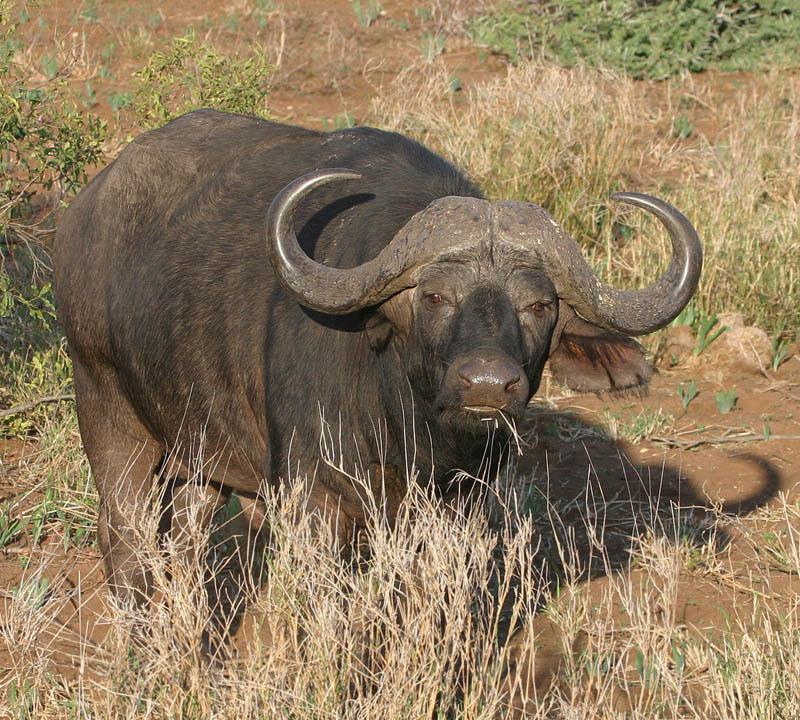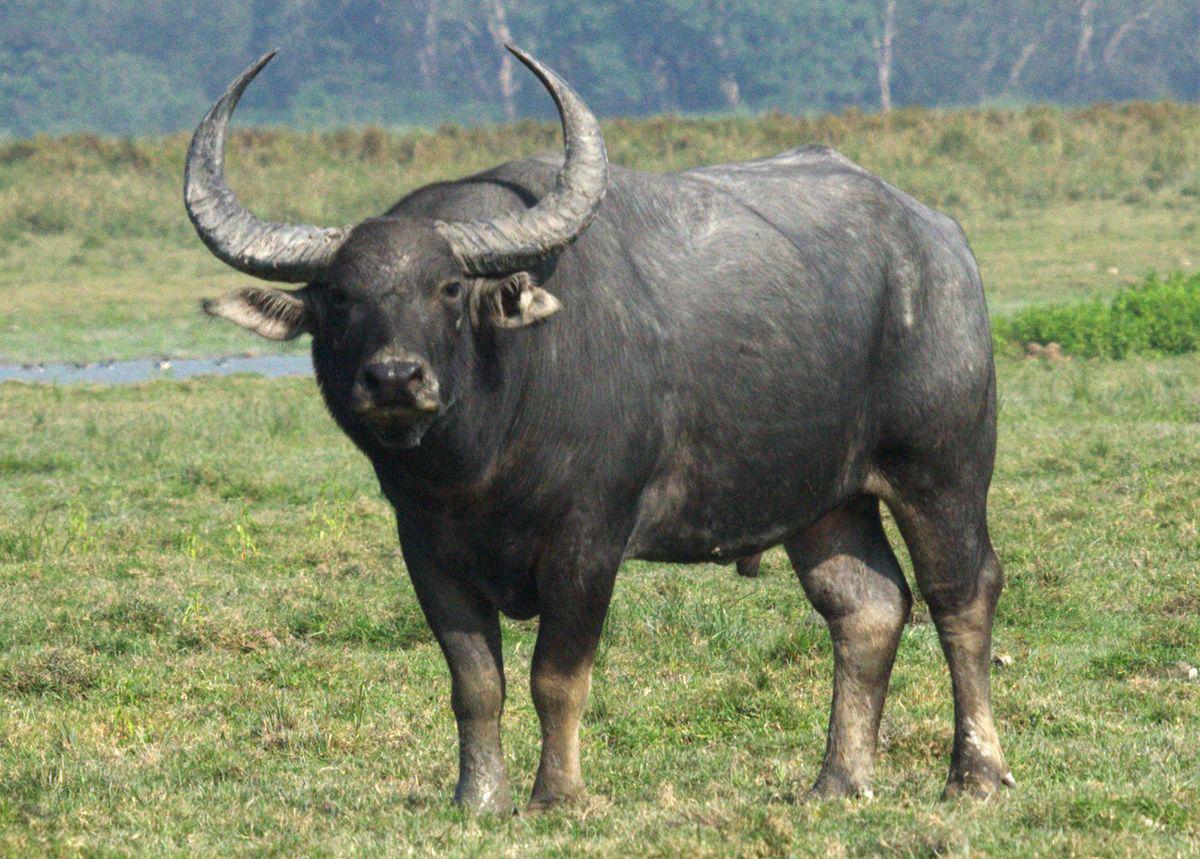The first image is the image on the left, the second image is the image on the right. Assess this claim about the two images: "There are 2 wild cattle.". Correct or not? Answer yes or no. Yes. 